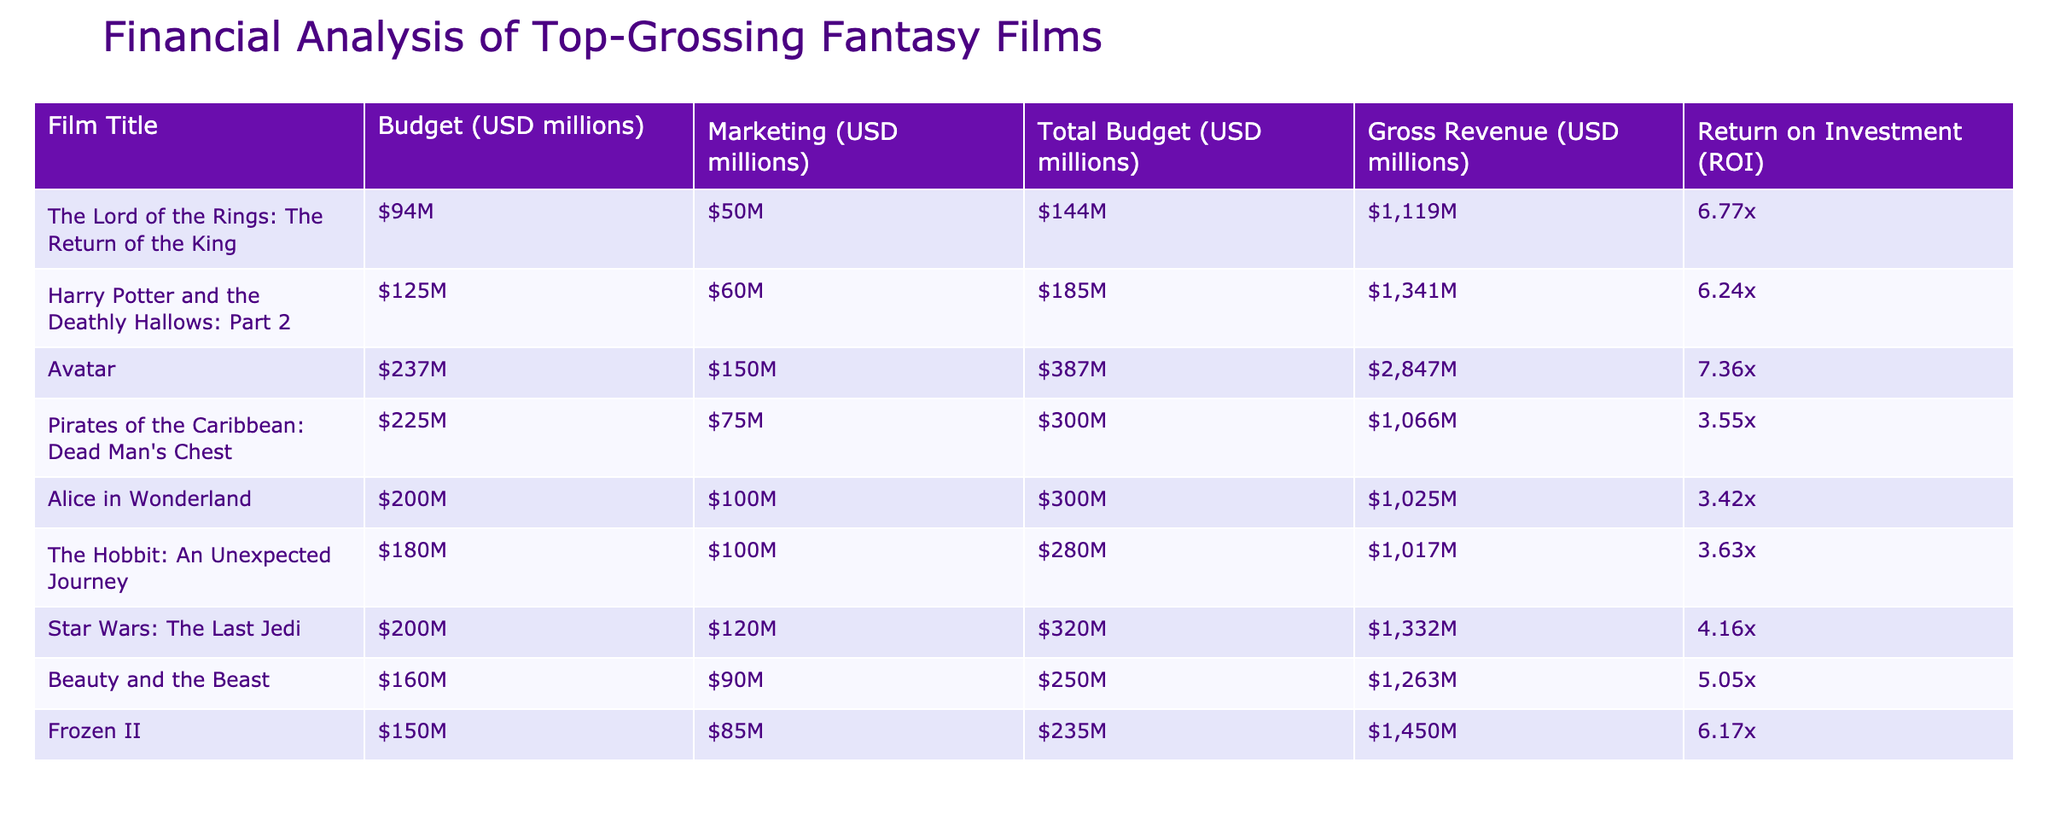What is the gross revenue of "Avatar"? The table shows that the gross revenue for "Avatar" is listed in the appropriate column, where it states that it earned $2,847 million.
Answer: $2,847 million Which film had the highest return on investment (ROI)? By comparing the ROI values in the table, "Avatar" has the highest return at 7.36x, as it is the highest figure in the ROI column.
Answer: 7.36x What is the total budget for "Harry Potter and the Deathly Hallows: Part 2"? The total budget for "Harry Potter and the Deathly Hallows: Part 2" is in the respective column with the value $185 million directly listed alongside the film title.
Answer: $185 million What is the average ROI of the films listed? To calculate the average ROI, we sum up all the ROI values (6.77 + 6.24 + 7.36 + 3.55 + 3.42 + 3.63 + 4.16 + 5.05 + 6.17) = 41.95. Since there are nine films, we divide 41.95 by 9, giving an average ROI of approximately 4.66.
Answer: 4.66 Did "Frozen II" have a higher gross revenue than "The Hobbit: An Unexpected Journey"? Upon examining the gross revenue values, "Frozen II" earned $1,450 million, while "The Hobbit: An Unexpected Journey" earned $1,017 million. Since 1,450 is greater than 1,017, the statement is true.
Answer: Yes What is the difference in total budget between "The Lord of the Rings: The Return of the King" and "Pirates of the Caribbean: Dead Man's Chest"? The total budget for "The Lord of the Rings: The Return of the King" is $144 million, and for "Pirates of the Caribbean: Dead Man's Chest" it is $300 million. The difference is calculated as $300 million - $144 million = $156 million.
Answer: $156 million How many films have an ROI greater than 5? Reviewing the ROI column, the films with an ROI greater than 5 are: "The Lord of the Rings: The Return of the King," "Harry Potter and the Deathly Hallows: Part 2," "Avatar," "Beauty and the Beast," and "Frozen II." This totals to five films.
Answer: 5 films Is the marketing cost of "Alice in Wonderland" higher than $90 million? The table shows the marketing cost for "Alice in Wonderland" is $100 million, which is indeed higher than $90 million, making this statement true.
Answer: Yes What percentage of the total budget of "Star Wars: The Last Jedi" was allocated to marketing? The total budget for "Star Wars: The Last Jedi" is $320 million, and the marketing cost is $120 million. The percentage is calculated as (120/320) * 100 = 37.5%.
Answer: 37.5% 